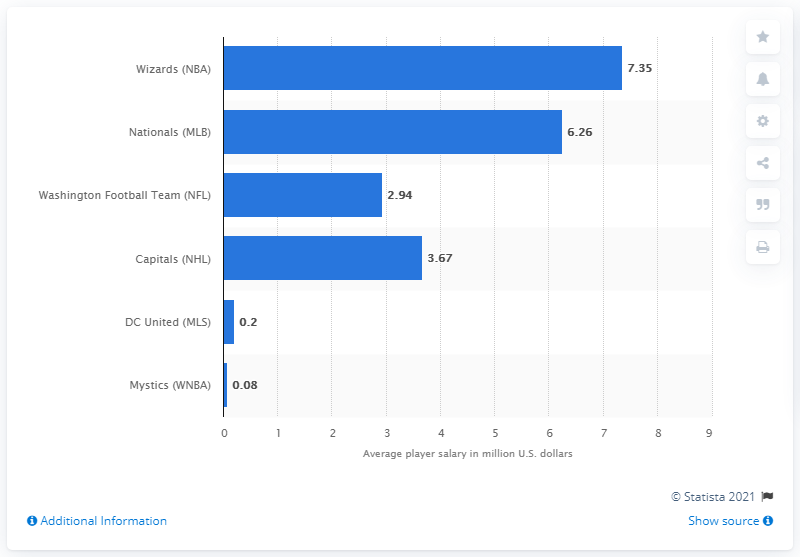Give some essential details in this illustration. The average player salary for the Washington Wizards in 2017 was 7.35. 